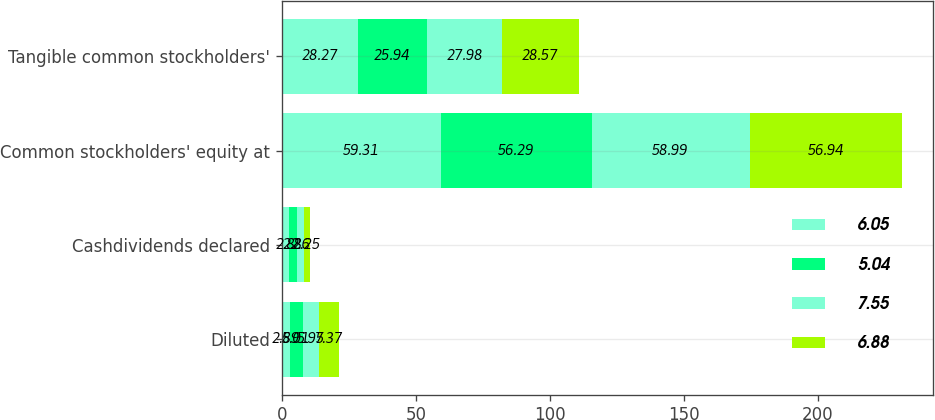Convert chart to OTSL. <chart><loc_0><loc_0><loc_500><loc_500><stacked_bar_chart><ecel><fcel>Diluted<fcel>Cashdividends declared<fcel>Common stockholders' equity at<fcel>Tangible common stockholders'<nl><fcel>6.05<fcel>2.89<fcel>2.8<fcel>59.31<fcel>28.27<nl><fcel>5.04<fcel>5.01<fcel>2.8<fcel>56.29<fcel>25.94<nl><fcel>7.55<fcel>5.95<fcel>2.6<fcel>58.99<fcel>27.98<nl><fcel>6.88<fcel>7.37<fcel>2.25<fcel>56.94<fcel>28.57<nl></chart> 